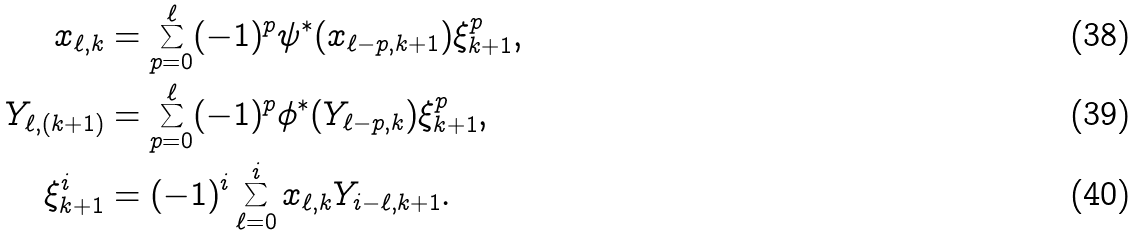Convert formula to latex. <formula><loc_0><loc_0><loc_500><loc_500>x _ { \ell , k } & = \sum _ { p = 0 } ^ { \ell } ( - 1 ) ^ { p } \psi ^ { * } ( x _ { \ell - p , k + 1 } ) \xi _ { k + 1 } ^ { p } , \\ Y _ { \ell , ( k + 1 ) } & = \sum _ { p = 0 } ^ { \ell } ( - 1 ) ^ { p } \phi ^ { * } ( Y _ { \ell - p , k } ) \xi _ { k + 1 } ^ { p } , \\ \xi _ { k + 1 } ^ { i } & = ( - 1 ) ^ { i } \sum _ { \ell = 0 } ^ { i } x _ { \ell , k } Y _ { i - \ell , k + 1 } .</formula> 